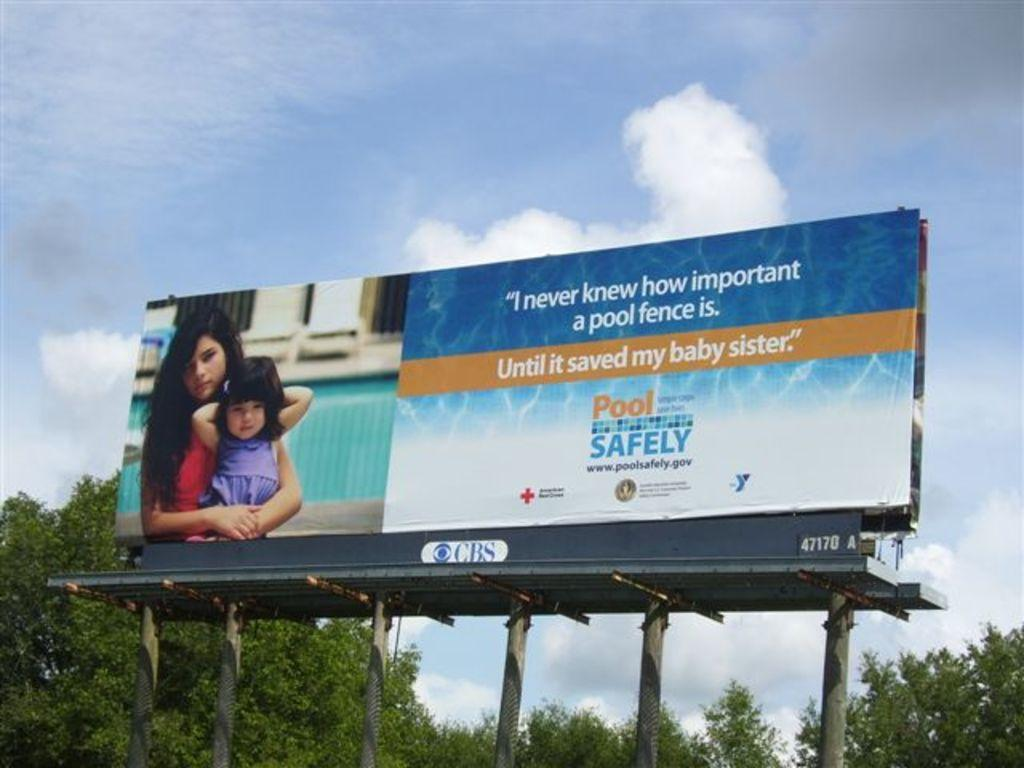What is located in the foreground of the image? There is a hoarding, two persons, pillars, and metal rods in the foreground of the image. What can be seen on the hoarding? There is text visible on the hoarding. What is visible in the background of the image? Trees and the sky are visible in the background of the image. Can you describe the time of day when the image was likely taken? The image was likely taken during the day, as the sky is visible and not dark. What type of fruit is hanging from the metal rods in the image? There is no fruit hanging from the metal rods in the image. Can you describe the wing of the bird that is flying in the image? There are no birds or wings visible in the image. 